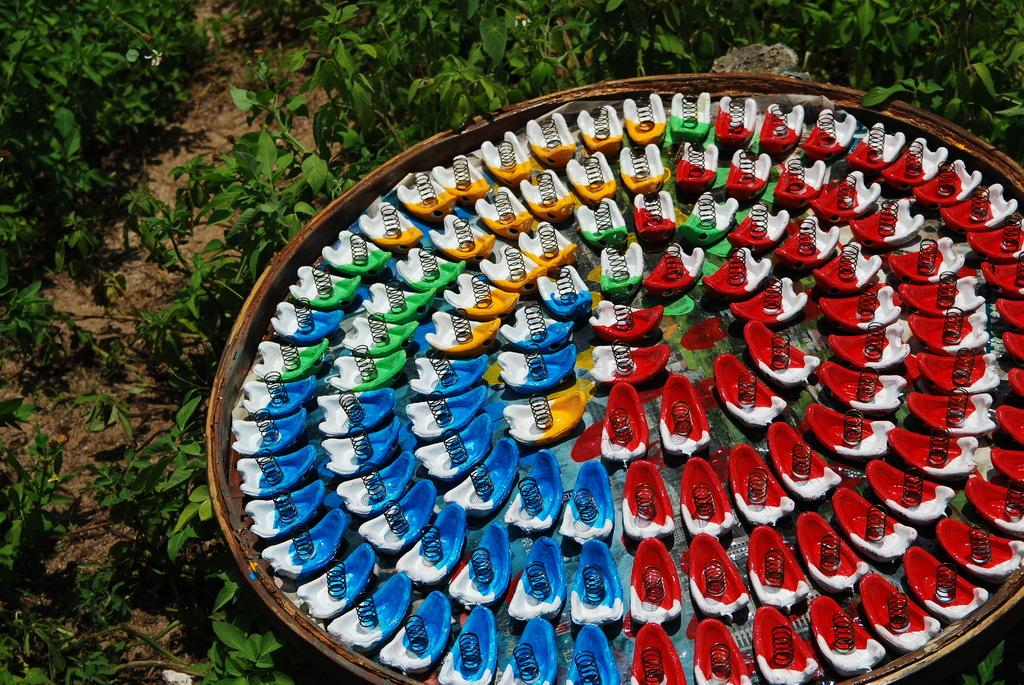What type of objects are present in the image that have springs? There are objects with springs in the image. How are the springs arranged in the image? The springs have formed circles. Where are these objects with springs located? These objects are on a big plate. What can be seen in the background of the image? There are plants in the background of the image. How are the plants positioned in the image? The plants are on the ground. What type of animals can be seen in the zoo in the image? There is no zoo or animals present in the image; it features objects with springs, a big plate, and plants in the background. 